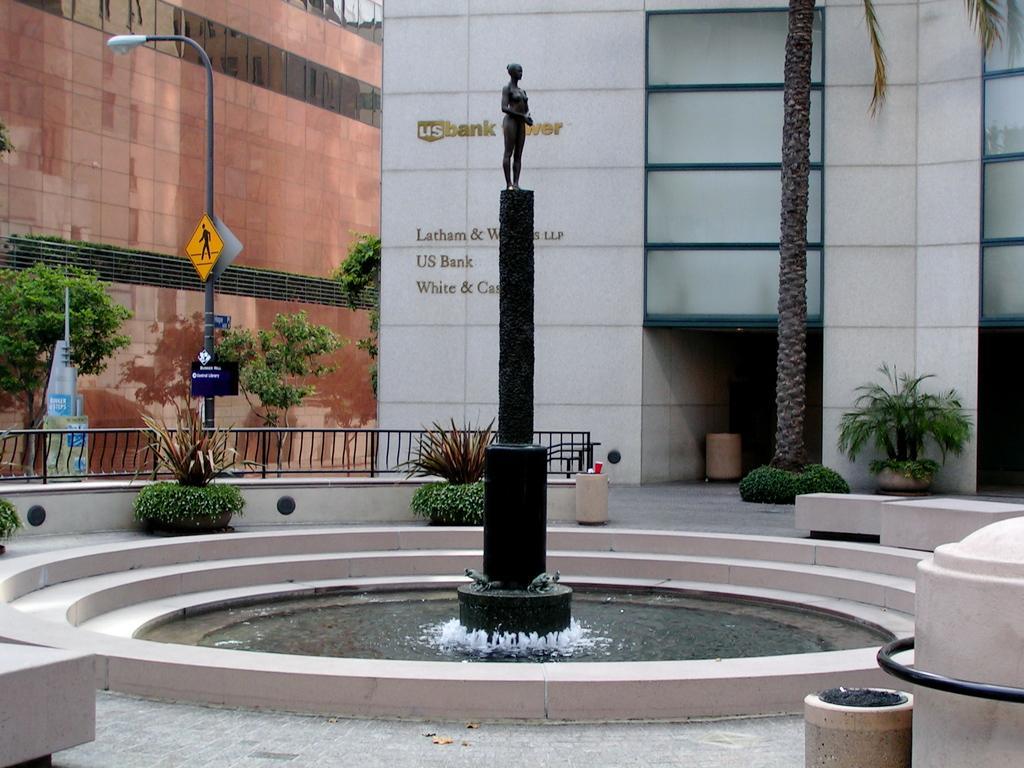How would you summarize this image in a sentence or two? In the center of the image there is statue. At the bottom of the image there is floor. In the background of the image there are buildings, trees, plants, light pole, fencing. There is some text on the wall in the background of the image. 